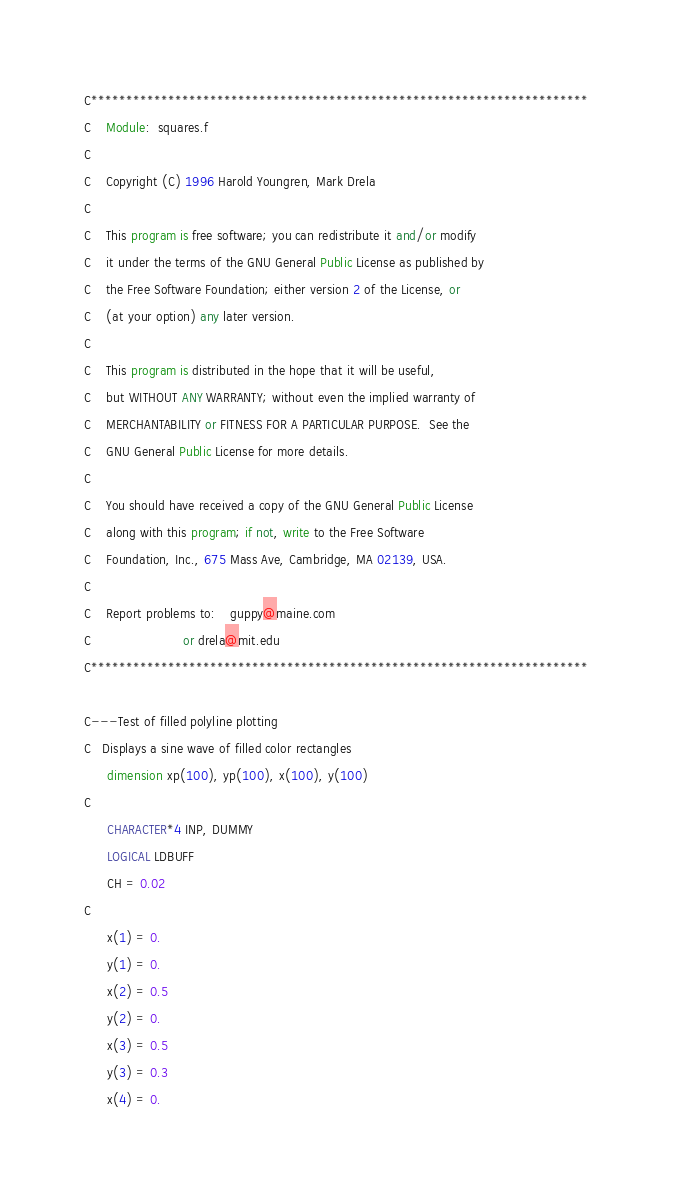<code> <loc_0><loc_0><loc_500><loc_500><_FORTRAN_>C*********************************************************************** 
C    Module:  squares.f
C 
C    Copyright (C) 1996 Harold Youngren, Mark Drela 
C 
C    This program is free software; you can redistribute it and/or modify 
C    it under the terms of the GNU General Public License as published by 
C    the Free Software Foundation; either version 2 of the License, or 
C    (at your option) any later version. 
C 
C    This program is distributed in the hope that it will be useful, 
C    but WITHOUT ANY WARRANTY; without even the implied warranty of 
C    MERCHANTABILITY or FITNESS FOR A PARTICULAR PURPOSE.  See the 
C    GNU General Public License for more details. 
C 
C    You should have received a copy of the GNU General Public License 
C    along with this program; if not, write to the Free Software 
C    Foundation, Inc., 675 Mass Ave, Cambridge, MA 02139, USA. 
C
C    Report problems to:    guppy@maine.com 
C                        or drela@mit.edu  
C*********************************************************************** 

C---Test of filled polyline plotting
C   Displays a sine wave of filled color rectangles
      dimension xp(100), yp(100), x(100), y(100)
C
      CHARACTER*4 INP, DUMMY
      LOGICAL LDBUFF
      CH = 0.02
C
      x(1) = 0.
      y(1) = 0.
      x(2) = 0.5
      y(2) = 0.
      x(3) = 0.5
      y(3) = 0.3
      x(4) = 0.</code> 